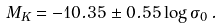Convert formula to latex. <formula><loc_0><loc_0><loc_500><loc_500>M _ { K } = - 1 0 . 3 5 \pm 0 . 5 5 \log \sigma _ { 0 } \, .</formula> 